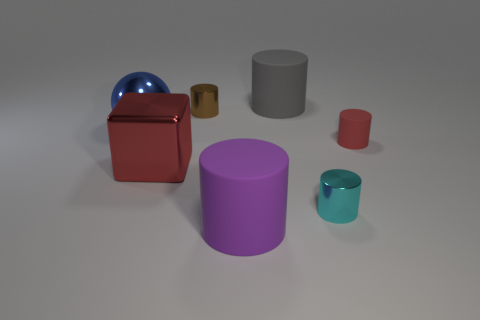What shape is the tiny matte thing that is the same color as the big cube?
Your answer should be very brief. Cylinder. How many small cylinders have the same color as the large cube?
Your response must be concise. 1. Does the gray rubber thing have the same size as the red rubber object?
Give a very brief answer. No. What is the size of the purple rubber thing that is the same shape as the gray matte thing?
Provide a short and direct response. Large. What material is the red object that is to the left of the tiny metal thing in front of the brown shiny thing made of?
Make the answer very short. Metal. Is the shape of the gray rubber object the same as the cyan metal thing?
Provide a succinct answer. Yes. What number of metallic objects are on the right side of the red shiny cube and in front of the large blue metallic thing?
Your answer should be compact. 1. Are there the same number of small brown metal objects that are in front of the brown thing and red things on the left side of the large blue shiny sphere?
Your answer should be compact. Yes. Is the size of the metal cylinder that is behind the red cylinder the same as the metal thing that is on the right side of the big purple thing?
Offer a terse response. Yes. The object that is on the left side of the cyan metallic cylinder and in front of the large cube is made of what material?
Ensure brevity in your answer.  Rubber. 